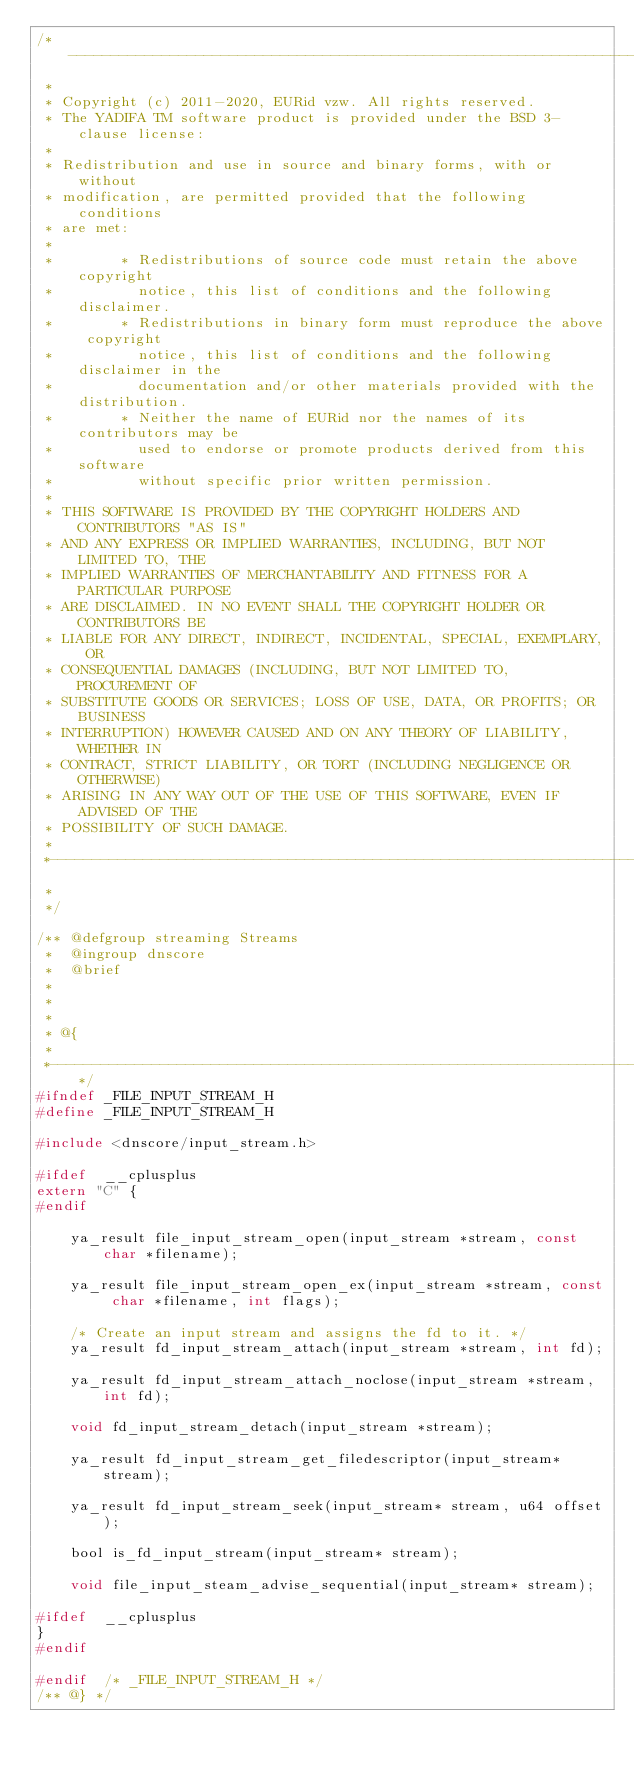<code> <loc_0><loc_0><loc_500><loc_500><_C_>/*------------------------------------------------------------------------------
 *
 * Copyright (c) 2011-2020, EURid vzw. All rights reserved.
 * The YADIFA TM software product is provided under the BSD 3-clause license:
 *
 * Redistribution and use in source and binary forms, with or without
 * modification, are permitted provided that the following conditions
 * are met:
 *
 *        * Redistributions of source code must retain the above copyright
 *          notice, this list of conditions and the following disclaimer.
 *        * Redistributions in binary form must reproduce the above copyright
 *          notice, this list of conditions and the following disclaimer in the
 *          documentation and/or other materials provided with the distribution.
 *        * Neither the name of EURid nor the names of its contributors may be
 *          used to endorse or promote products derived from this software
 *          without specific prior written permission.
 *
 * THIS SOFTWARE IS PROVIDED BY THE COPYRIGHT HOLDERS AND CONTRIBUTORS "AS IS"
 * AND ANY EXPRESS OR IMPLIED WARRANTIES, INCLUDING, BUT NOT LIMITED TO, THE
 * IMPLIED WARRANTIES OF MERCHANTABILITY AND FITNESS FOR A PARTICULAR PURPOSE
 * ARE DISCLAIMED. IN NO EVENT SHALL THE COPYRIGHT HOLDER OR CONTRIBUTORS BE
 * LIABLE FOR ANY DIRECT, INDIRECT, INCIDENTAL, SPECIAL, EXEMPLARY, OR
 * CONSEQUENTIAL DAMAGES (INCLUDING, BUT NOT LIMITED TO, PROCUREMENT OF
 * SUBSTITUTE GOODS OR SERVICES; LOSS OF USE, DATA, OR PROFITS; OR BUSINESS
 * INTERRUPTION) HOWEVER CAUSED AND ON ANY THEORY OF LIABILITY, WHETHER IN
 * CONTRACT, STRICT LIABILITY, OR TORT (INCLUDING NEGLIGENCE OR OTHERWISE)
 * ARISING IN ANY WAY OUT OF THE USE OF THIS SOFTWARE, EVEN IF ADVISED OF THE
 * POSSIBILITY OF SUCH DAMAGE.
 *
 *------------------------------------------------------------------------------
 *
 */

/** @defgroup streaming Streams
 *  @ingroup dnscore
 *  @brief 
 *
 *  
 *
 * @{
 *
 *----------------------------------------------------------------------------*/
#ifndef _FILE_INPUT_STREAM_H
#define	_FILE_INPUT_STREAM_H

#include <dnscore/input_stream.h>

#ifdef	__cplusplus
extern "C" {
#endif

    ya_result file_input_stream_open(input_stream *stream, const char *filename);
    
    ya_result file_input_stream_open_ex(input_stream *stream, const char *filename, int flags);
    
    /* Create an input stream and assigns the fd to it. */
    ya_result fd_input_stream_attach(input_stream *stream, int fd);
        
    ya_result fd_input_stream_attach_noclose(input_stream *stream, int fd);
    
    void fd_input_stream_detach(input_stream *stream);

    ya_result fd_input_stream_get_filedescriptor(input_stream* stream);
    
    ya_result fd_input_stream_seek(input_stream* stream, u64 offset);

    bool is_fd_input_stream(input_stream* stream);
    
    void file_input_steam_advise_sequential(input_stream* stream);
    
#ifdef	__cplusplus
}
#endif

#endif	/* _FILE_INPUT_STREAM_H */
/** @} */
</code> 